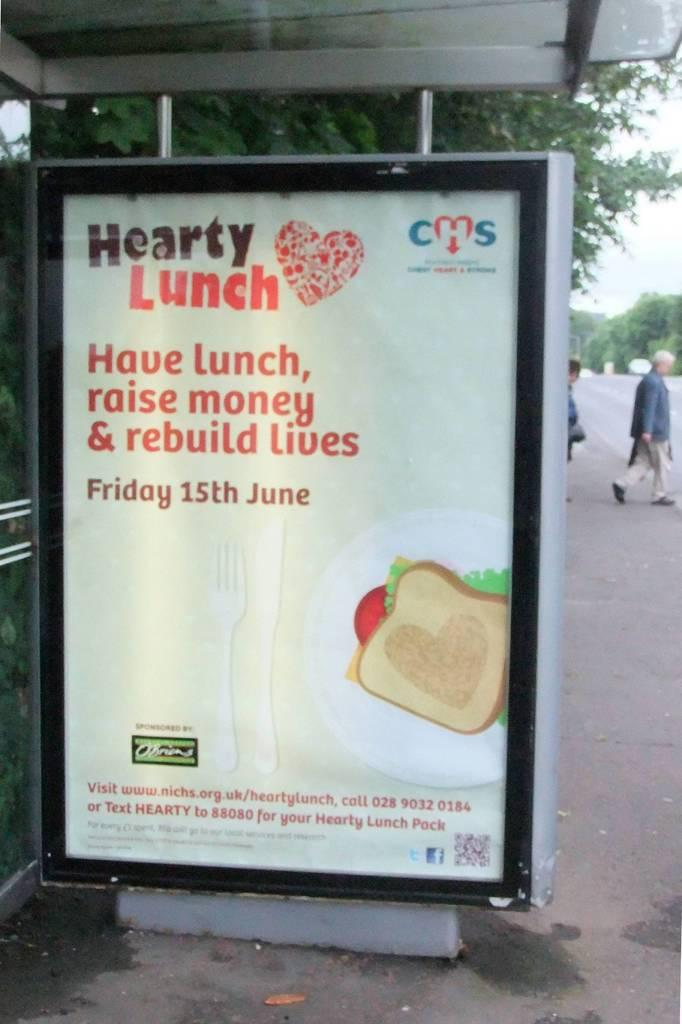<image>
Relay a brief, clear account of the picture shown. A sign showing a sandwich is advertising a fundraiser on the 15th of June. 